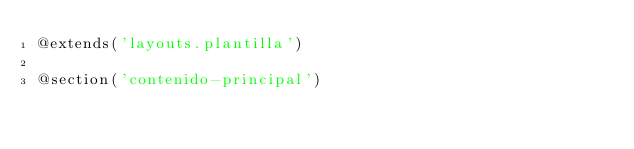Convert code to text. <code><loc_0><loc_0><loc_500><loc_500><_PHP_>@extends('layouts.plantilla')

@section('contenido-principal')
</code> 